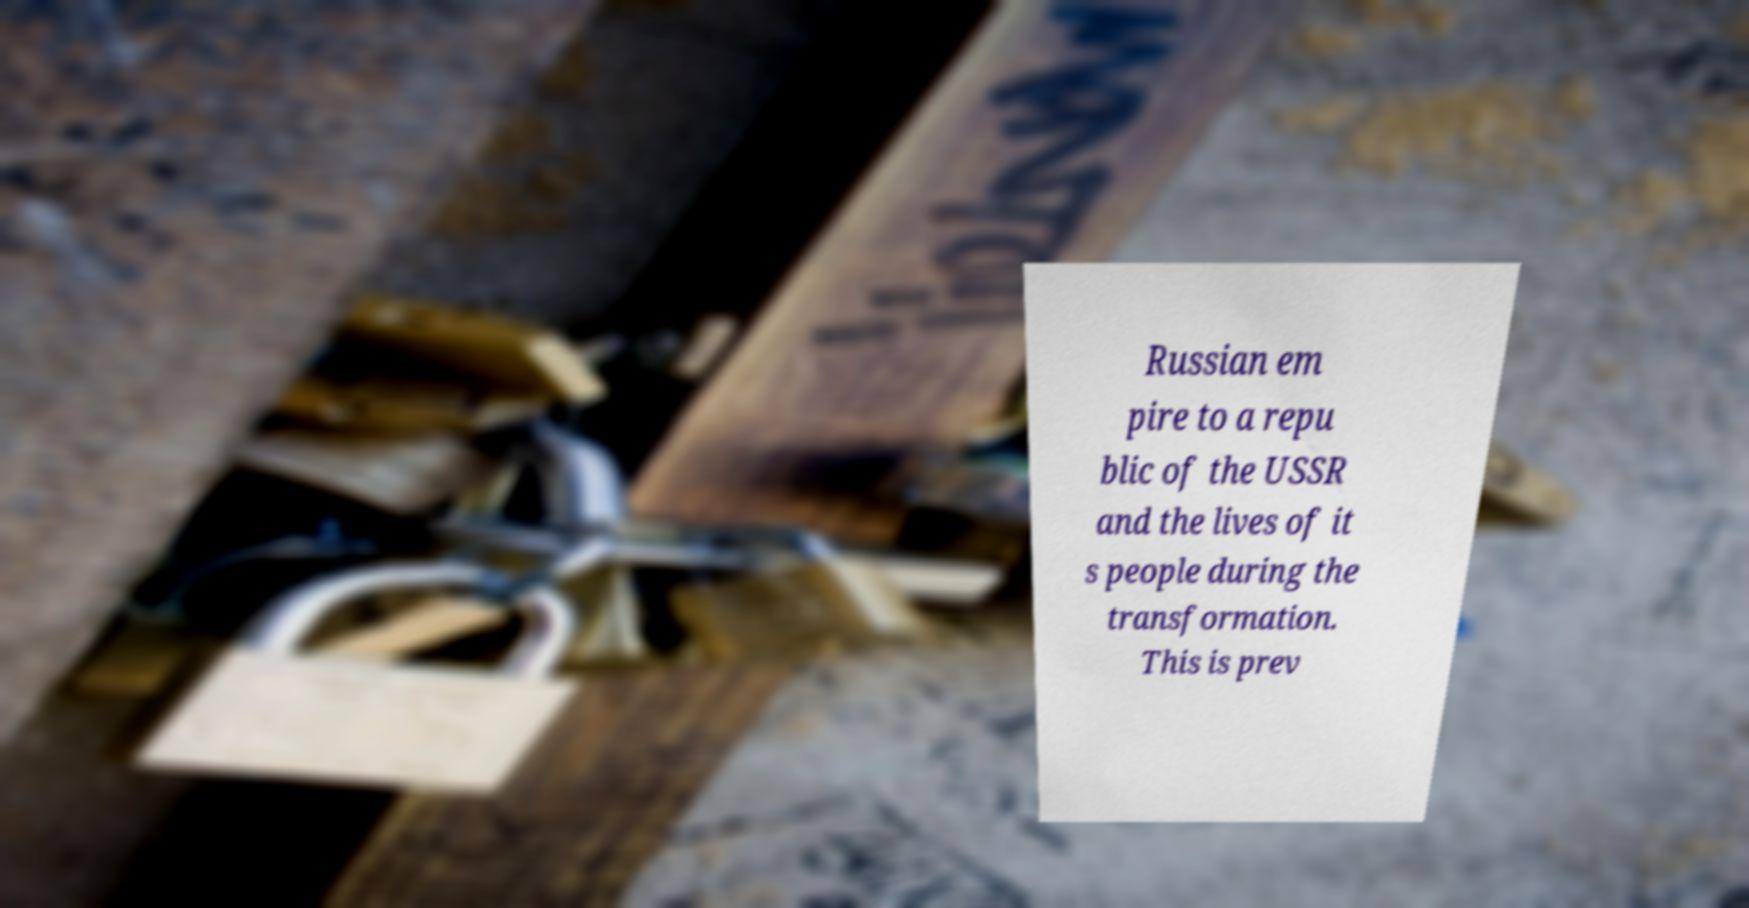I need the written content from this picture converted into text. Can you do that? Russian em pire to a repu blic of the USSR and the lives of it s people during the transformation. This is prev 